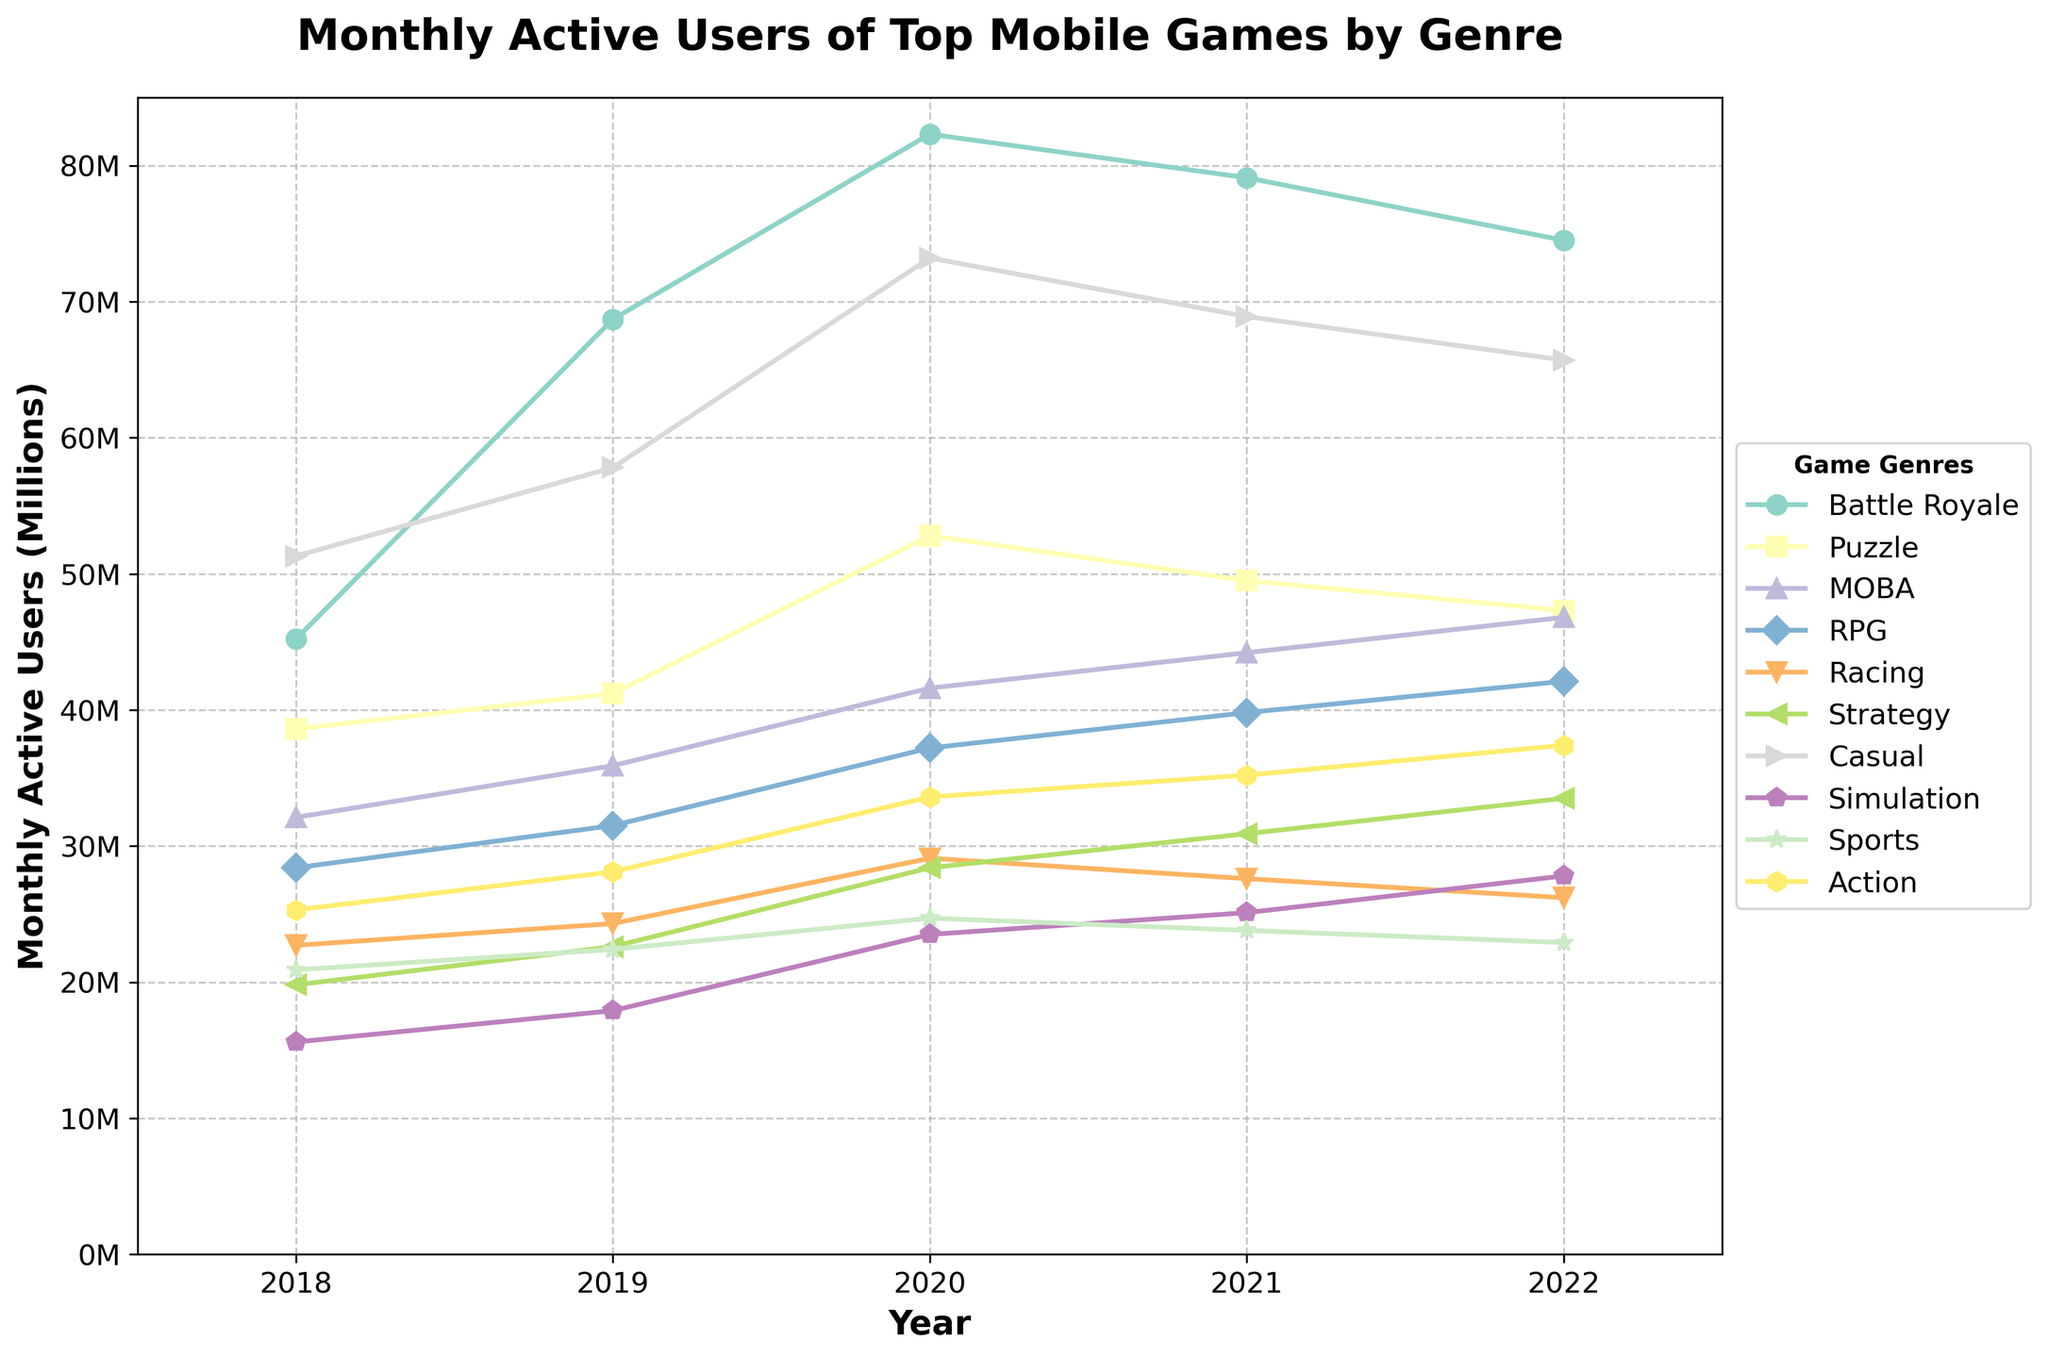what genre had the highest number of monthly active users in 2022? The graph shows various genres with their respective monthly active users. By looking at the 2022 data points, we can see that the Battle Royale genre had the highest number of monthly active users.
Answer: Battle Royale which genre had the most significant growth in monthly active users from 2018 to 2022? Calculate the difference for each genre between 2022 and 2018. Battle Royale: 74.5 - 45.2 = 29.3, Puzzle: 47.3 - 38.6 = 8.7, MOBA: 46.8 - 32.1 = 14.7, RPG: 42.1 - 28.4 = 13.7, Racing: 26.2 - 22.7 = 3.5, Strategy: 33.5 - 19.8 = 13.7, Casual: 65.7 - 51.3 = 14.4, Simulation: 27.8 - 15.6 = 12.2, Sports: 22.9 - 20.9 = 2.0, Action: 37.4 - 25.3 = 12.1. Battle Royale had the most significant growth.
Answer: Battle Royale which genre experienced a decline in monthly active users from 2021 to 2022? Analyse the difference between the 2021 and 2022 data points for each genre. Battle Royale: 79.1 - 74.5 = -4.6, Puzzle: 49.5 - 47.3 = -2.2, MOBA: 44.2 - 46.8 = +2.6, RPG: 39.8 - 42.1 = +2.3, Racing: 27.6 - 26.2 = -1.4, Strategy: 30.9 - 33.5 = +2.6, Casual: 68.9 - 65.7 = -3.2, Simulation: 25.1 - 27.8 = +2.7, Sports: 23.8 - 22.9 = -0.9, Action: 35.2 - 37.4 = +2.2. The genres Battle Royale, Puzzle, Racing, Casual, and Sports experienced a decline.
Answer: Battle Royale, Puzzle, Racing, Casual, and Sports what is the average number of monthly active users for the Sports genre from 2018 to 2022? Sum the monthly active users for the Sports genre from 2018 to 2022: 20.9 + 22.4 + 24.7 + 23.8 + 22.9 = 114.7. Then, divide by the number of years (5): 114.7 / 5 = 22.94.
Answer: 22.94 which genre had more monthly active users in 2020, RPG or Racing? Compare the values for the year 2020 for RPG (37.2) and Racing (29.1). RPG had more monthly active users in 2020.
Answer: RPG how many genres reached their peak monthly active users in 2020? Check each genre to see if their highest value occurs in 2020. Battle Royale (no), Puzzle (yes), MOBA (no), RPG (no), Racing (no), Strategy (no), Casual (yes), Simulation (no), Sports (no), Action (no). Thus, two genres reached their peak in 2020.
Answer: 2 which two genres had a similar number of monthly active users in 2022? Look for genres with values close to each other in 2022. Puzzle: 47.3 and MOBA: 46.8 are quite close.
Answer: Puzzle and MOBA what is the total number of monthly active users for the Battle Royale genre from 2018 to 2022? Sum the monthly active users for the Battle Royale genre over the years: 45.2 + 68.7 + 82.3 + 79.1 + 74.5 = 349.8 million.
Answer: 349.8 million 